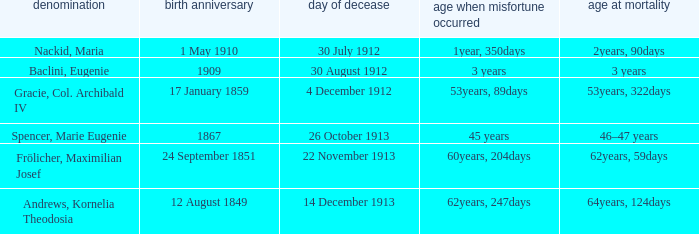How old was the person born 24 September 1851 at the time of disaster? 60years, 204days. 